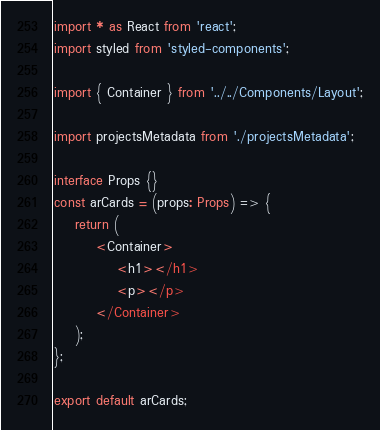<code> <loc_0><loc_0><loc_500><loc_500><_TypeScript_>import * as React from 'react';
import styled from 'styled-components';

import { Container } from '../../Components/Layout';

import projectsMetadata from './projectsMetadata';

interface Props {}
const arCards = (props: Props) => {
	return (
		<Container>
			<h1></h1>
			<p></p>
		</Container>
	);
};

export default arCards;
</code> 